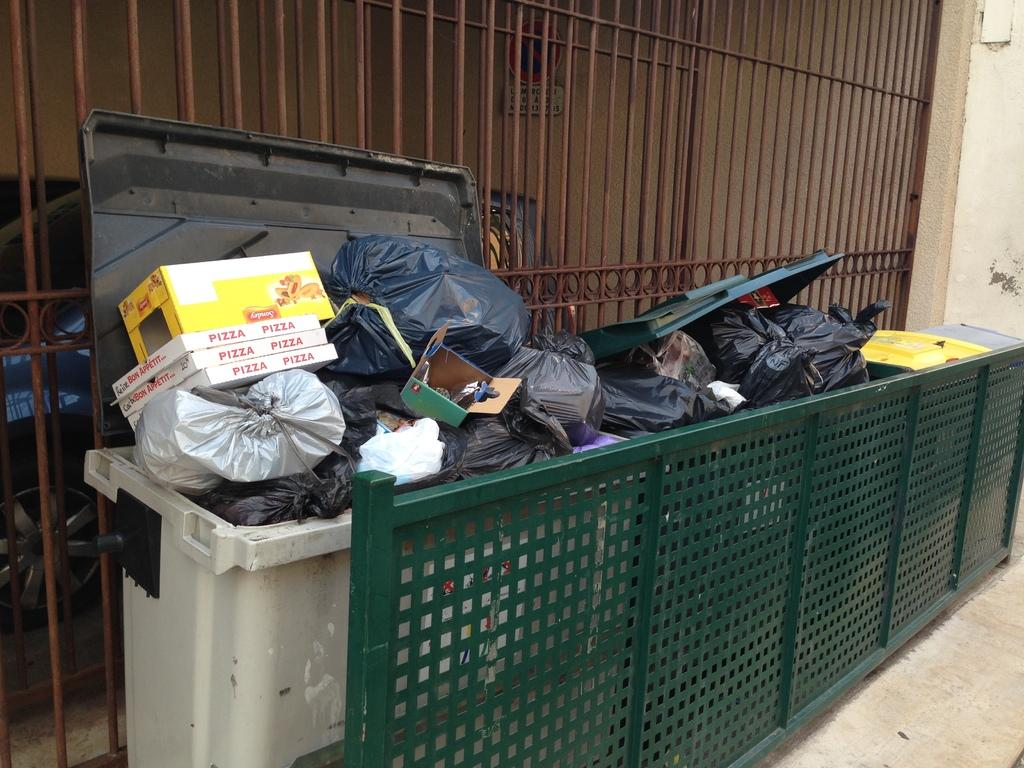<image>
Give a short and clear explanation of the subsequent image. Three pizza boxes and a yellow box with the word Sondey on it all sit in a dumpster. 